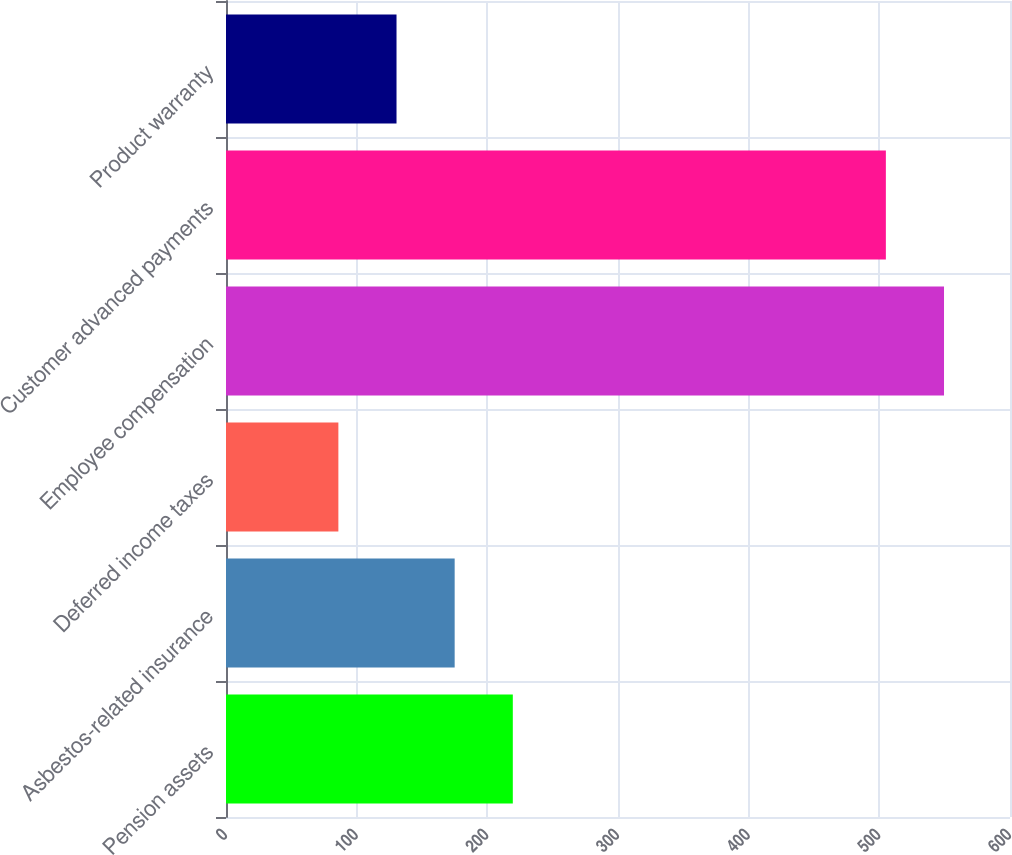<chart> <loc_0><loc_0><loc_500><loc_500><bar_chart><fcel>Pension assets<fcel>Asbestos-related insurance<fcel>Deferred income taxes<fcel>Employee compensation<fcel>Customer advanced payments<fcel>Product warranty<nl><fcel>219.5<fcel>175<fcel>86<fcel>549.5<fcel>505<fcel>130.5<nl></chart> 